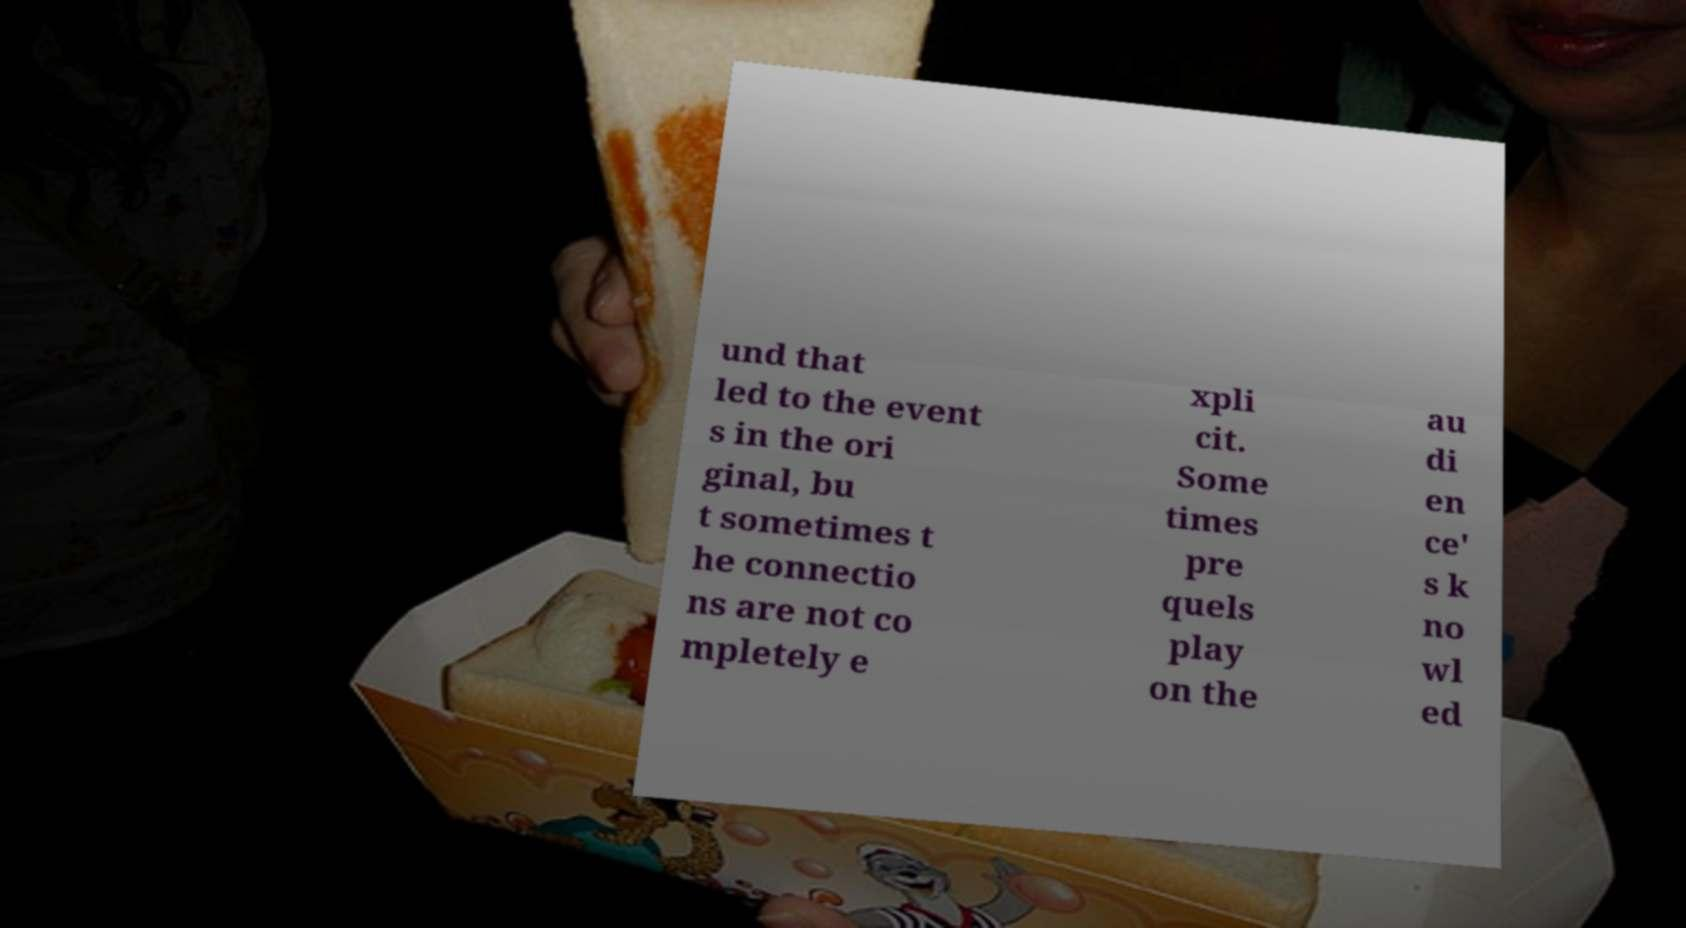Can you read and provide the text displayed in the image?This photo seems to have some interesting text. Can you extract and type it out for me? und that led to the event s in the ori ginal, bu t sometimes t he connectio ns are not co mpletely e xpli cit. Some times pre quels play on the au di en ce' s k no wl ed 